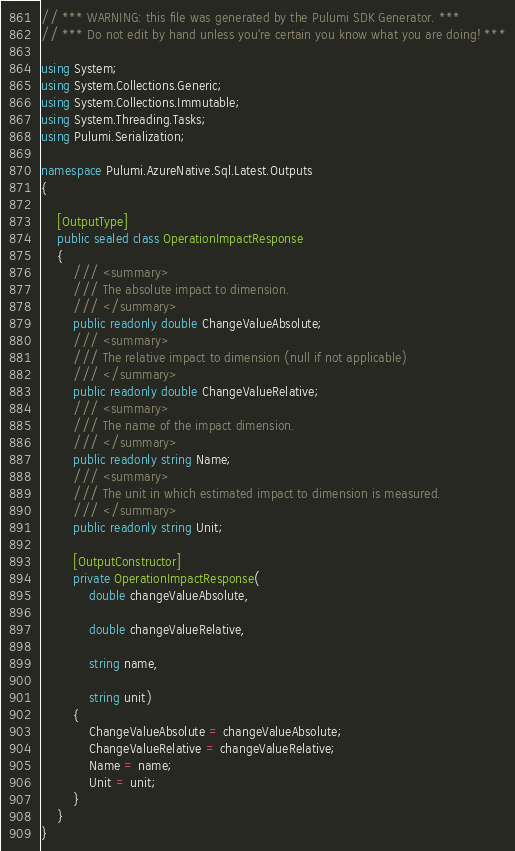Convert code to text. <code><loc_0><loc_0><loc_500><loc_500><_C#_>// *** WARNING: this file was generated by the Pulumi SDK Generator. ***
// *** Do not edit by hand unless you're certain you know what you are doing! ***

using System;
using System.Collections.Generic;
using System.Collections.Immutable;
using System.Threading.Tasks;
using Pulumi.Serialization;

namespace Pulumi.AzureNative.Sql.Latest.Outputs
{

    [OutputType]
    public sealed class OperationImpactResponse
    {
        /// <summary>
        /// The absolute impact to dimension.
        /// </summary>
        public readonly double ChangeValueAbsolute;
        /// <summary>
        /// The relative impact to dimension (null if not applicable)
        /// </summary>
        public readonly double ChangeValueRelative;
        /// <summary>
        /// The name of the impact dimension.
        /// </summary>
        public readonly string Name;
        /// <summary>
        /// The unit in which estimated impact to dimension is measured.
        /// </summary>
        public readonly string Unit;

        [OutputConstructor]
        private OperationImpactResponse(
            double changeValueAbsolute,

            double changeValueRelative,

            string name,

            string unit)
        {
            ChangeValueAbsolute = changeValueAbsolute;
            ChangeValueRelative = changeValueRelative;
            Name = name;
            Unit = unit;
        }
    }
}
</code> 